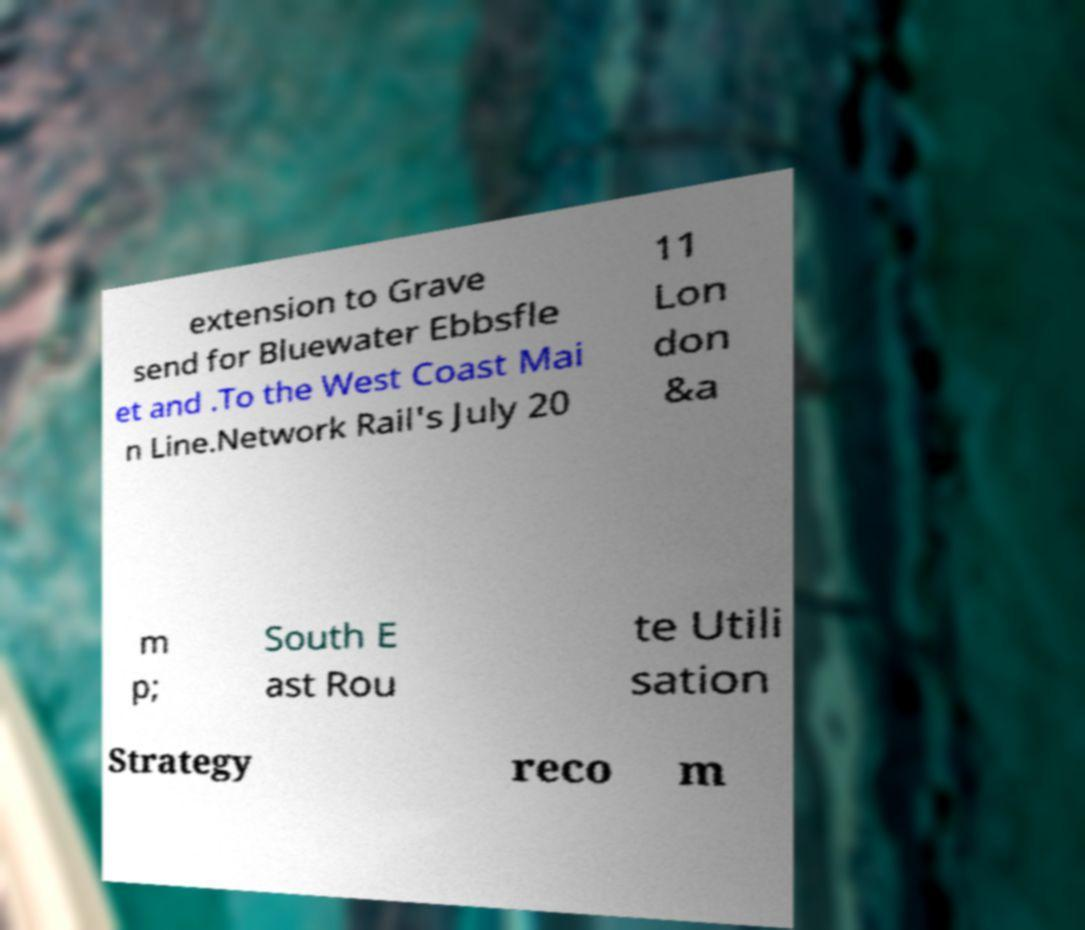For documentation purposes, I need the text within this image transcribed. Could you provide that? extension to Grave send for Bluewater Ebbsfle et and .To the West Coast Mai n Line.Network Rail's July 20 11 Lon don &a m p; South E ast Rou te Utili sation Strategy reco m 